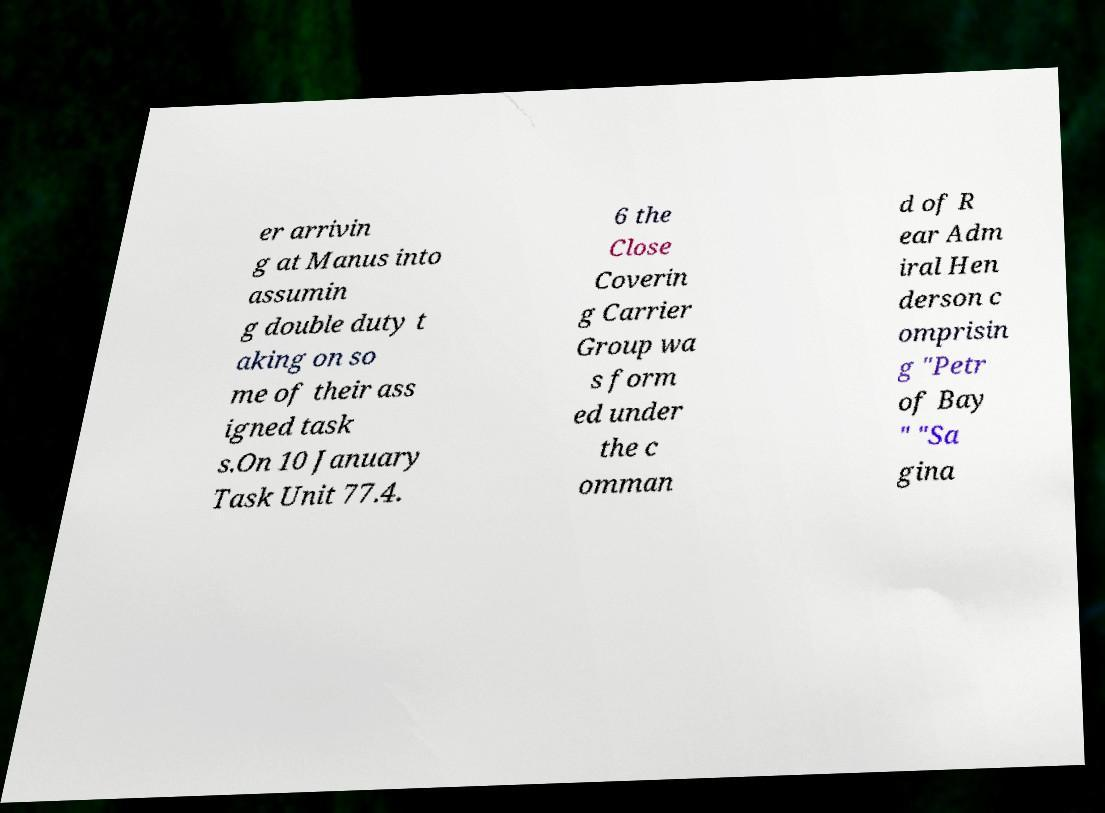Can you accurately transcribe the text from the provided image for me? er arrivin g at Manus into assumin g double duty t aking on so me of their ass igned task s.On 10 January Task Unit 77.4. 6 the Close Coverin g Carrier Group wa s form ed under the c omman d of R ear Adm iral Hen derson c omprisin g "Petr of Bay " "Sa gina 